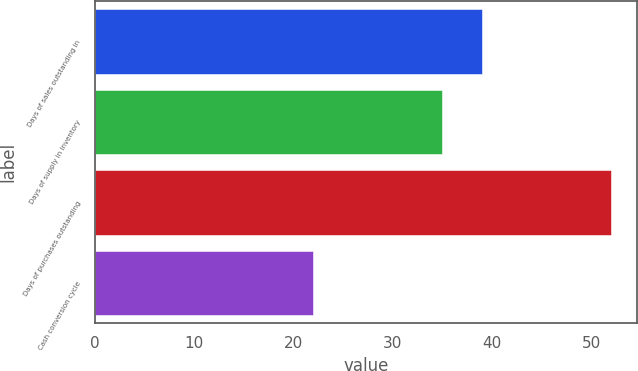Convert chart. <chart><loc_0><loc_0><loc_500><loc_500><bar_chart><fcel>Days of sales outstanding in<fcel>Days of supply in inventory<fcel>Days of purchases outstanding<fcel>Cash conversion cycle<nl><fcel>39<fcel>35<fcel>52<fcel>22<nl></chart> 